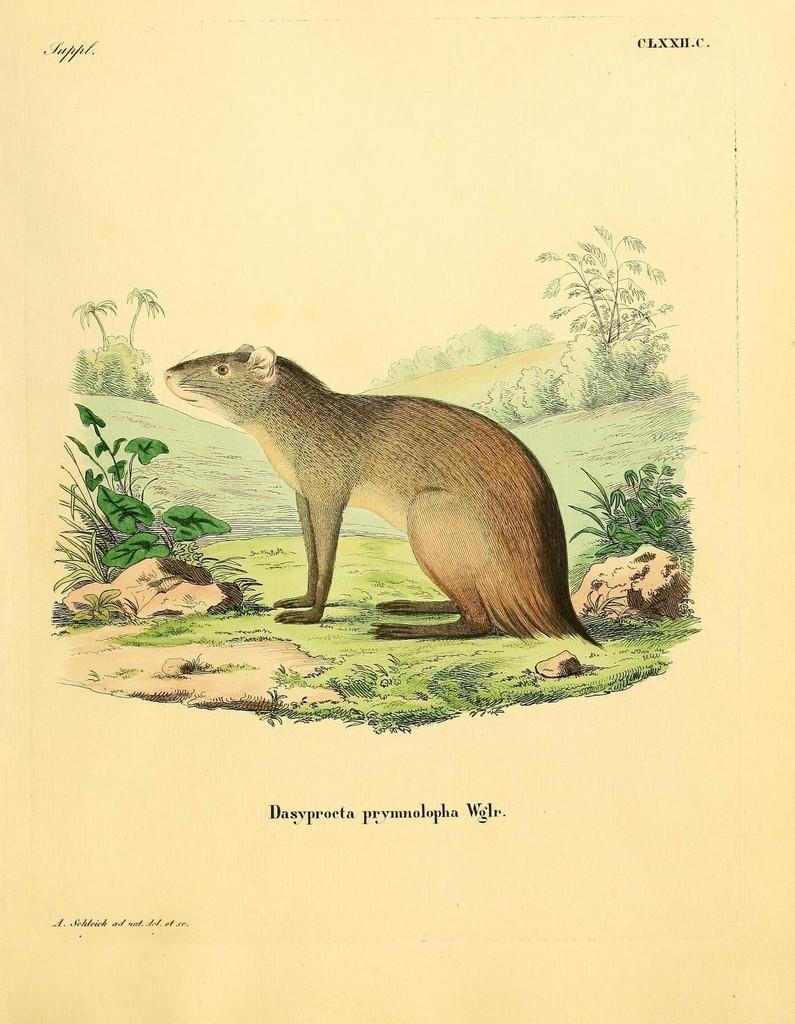Please provide a concise description of this image. In this picture I can see there is a animal, there's grass on the floor, there are few rocks. This is a drawing and there is something written at the bottom of the image. 